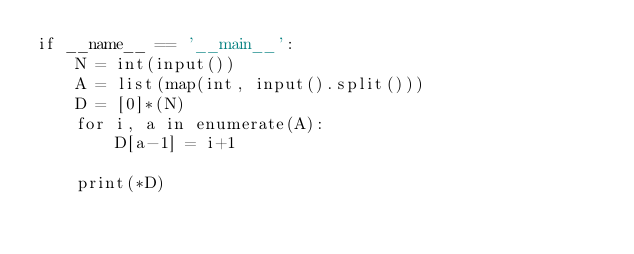<code> <loc_0><loc_0><loc_500><loc_500><_Python_>if __name__ == '__main__':
    N = int(input())
    A = list(map(int, input().split()))
    D = [0]*(N)
    for i, a in enumerate(A):
        D[a-1] = i+1
    
    print(*D)
</code> 